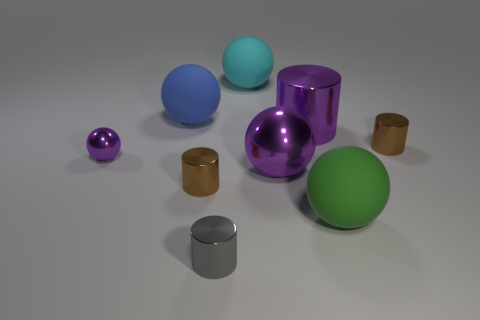Subtract all small purple shiny spheres. How many spheres are left? 4 Subtract all blue balls. How many balls are left? 4 Subtract 1 cylinders. How many cylinders are left? 3 Subtract all brown balls. Subtract all brown cylinders. How many balls are left? 5 Add 1 big objects. How many objects exist? 10 Subtract all cylinders. How many objects are left? 5 Subtract all big shiny cylinders. Subtract all small metal things. How many objects are left? 4 Add 4 large purple objects. How many large purple objects are left? 6 Add 3 blue matte objects. How many blue matte objects exist? 4 Subtract 1 brown cylinders. How many objects are left? 8 